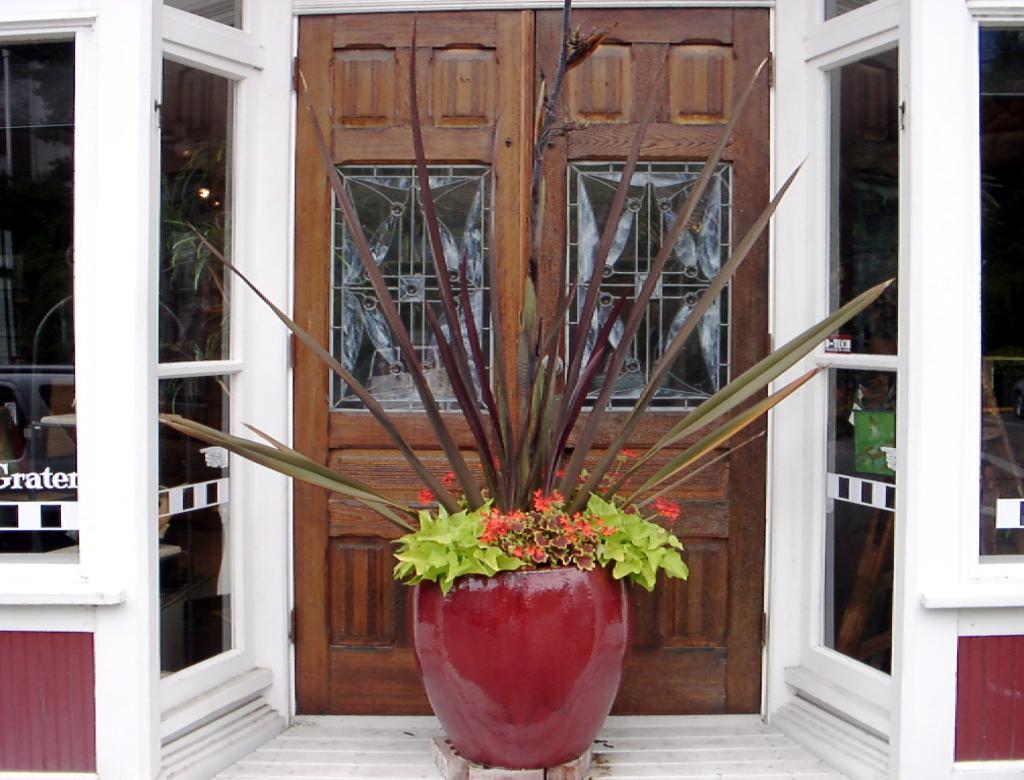Describe this image in one or two sentences. In this image in the middle there is a plant pot. In the background there is a building. This is a door. 